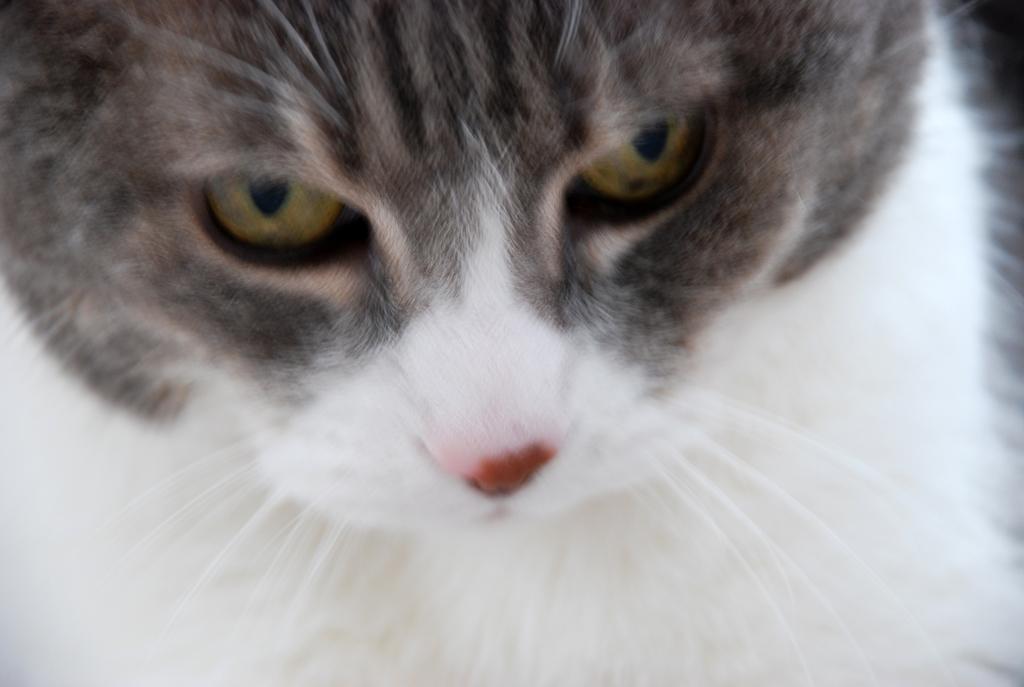Could you give a brief overview of what you see in this image? In this image I can see a cat off white and grey in color. This image is taken may be in a day. 